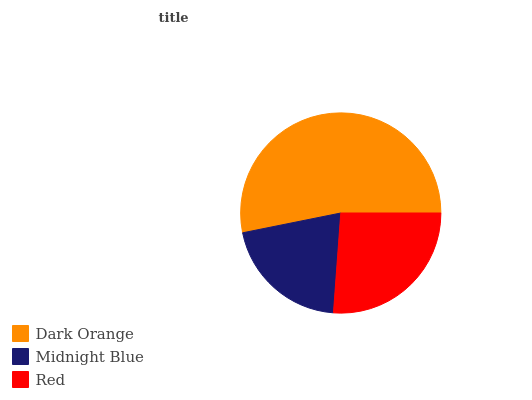Is Midnight Blue the minimum?
Answer yes or no. Yes. Is Dark Orange the maximum?
Answer yes or no. Yes. Is Red the minimum?
Answer yes or no. No. Is Red the maximum?
Answer yes or no. No. Is Red greater than Midnight Blue?
Answer yes or no. Yes. Is Midnight Blue less than Red?
Answer yes or no. Yes. Is Midnight Blue greater than Red?
Answer yes or no. No. Is Red less than Midnight Blue?
Answer yes or no. No. Is Red the high median?
Answer yes or no. Yes. Is Red the low median?
Answer yes or no. Yes. Is Dark Orange the high median?
Answer yes or no. No. Is Midnight Blue the low median?
Answer yes or no. No. 